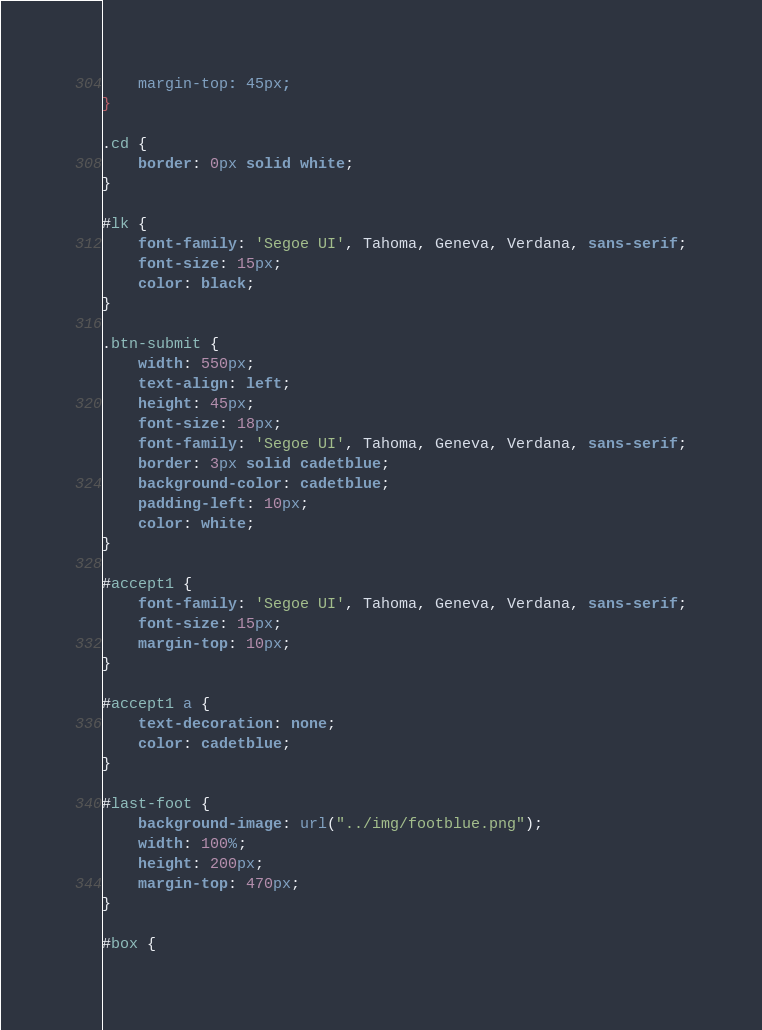<code> <loc_0><loc_0><loc_500><loc_500><_CSS_>    margin-top: 45px;
}

.cd {
    border: 0px solid white;
}

#lk {
    font-family: 'Segoe UI', Tahoma, Geneva, Verdana, sans-serif;
    font-size: 15px;
    color: black;
}

.btn-submit {
    width: 550px;
    text-align: left;
    height: 45px;
    font-size: 18px;
    font-family: 'Segoe UI', Tahoma, Geneva, Verdana, sans-serif;
    border: 3px solid cadetblue;
    background-color: cadetblue;
    padding-left: 10px;
    color: white;
}

#accept1 {
    font-family: 'Segoe UI', Tahoma, Geneva, Verdana, sans-serif;
    font-size: 15px;
    margin-top: 10px;
}

#accept1 a {
    text-decoration: none;
    color: cadetblue;
}

#last-foot {
    background-image: url("../img/footblue.png");
    width: 100%;
    height: 200px;
    margin-top: 470px;
}

#box {</code> 